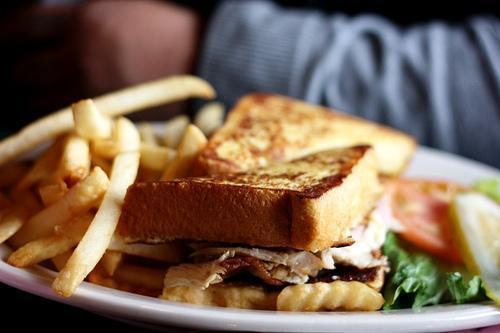How many plates on the table?
Give a very brief answer. 1. 